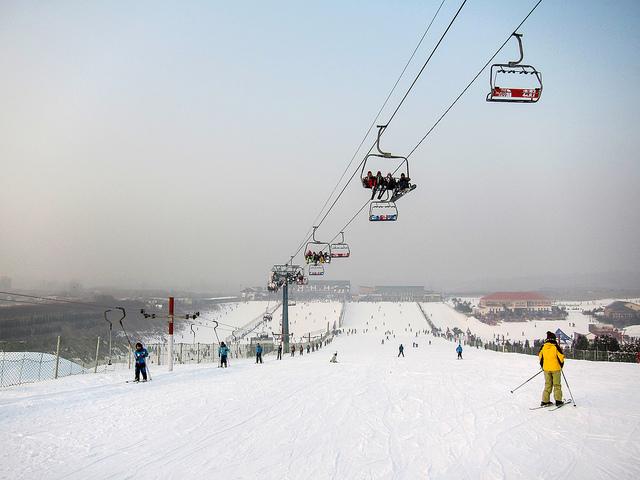What are these people up in the air on?
Short answer required. Ski lift. How many people are in the air?
Keep it brief. 12. Which side of the ski lift is going up?
Quick response, please. Right. How many buildings are in the image?
Write a very short answer. 1. Why is the guy in yellow just standing there?
Be succinct. Waiting. 